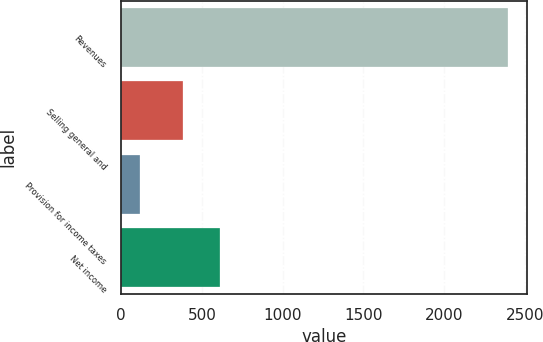Convert chart to OTSL. <chart><loc_0><loc_0><loc_500><loc_500><bar_chart><fcel>Revenues<fcel>Selling general and<fcel>Provision for income taxes<fcel>Net income<nl><fcel>2394.4<fcel>384<fcel>119.5<fcel>611.49<nl></chart> 